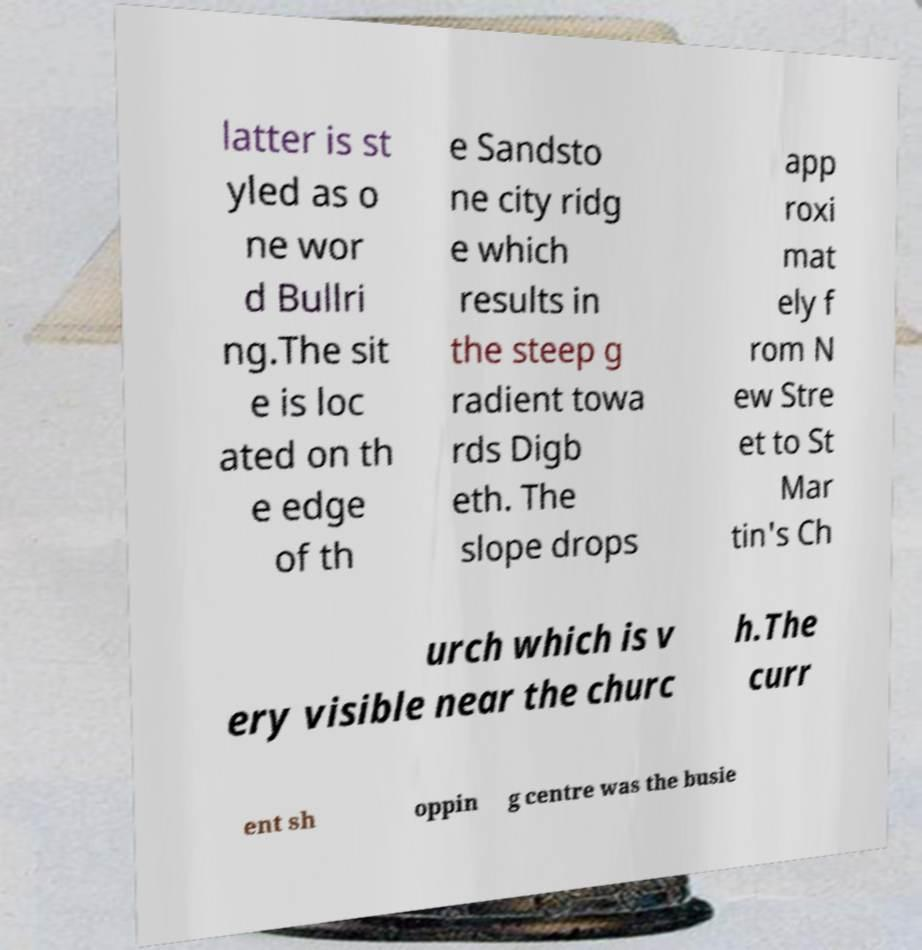Can you read and provide the text displayed in the image?This photo seems to have some interesting text. Can you extract and type it out for me? latter is st yled as o ne wor d Bullri ng.The sit e is loc ated on th e edge of th e Sandsto ne city ridg e which results in the steep g radient towa rds Digb eth. The slope drops app roxi mat ely f rom N ew Stre et to St Mar tin's Ch urch which is v ery visible near the churc h.The curr ent sh oppin g centre was the busie 